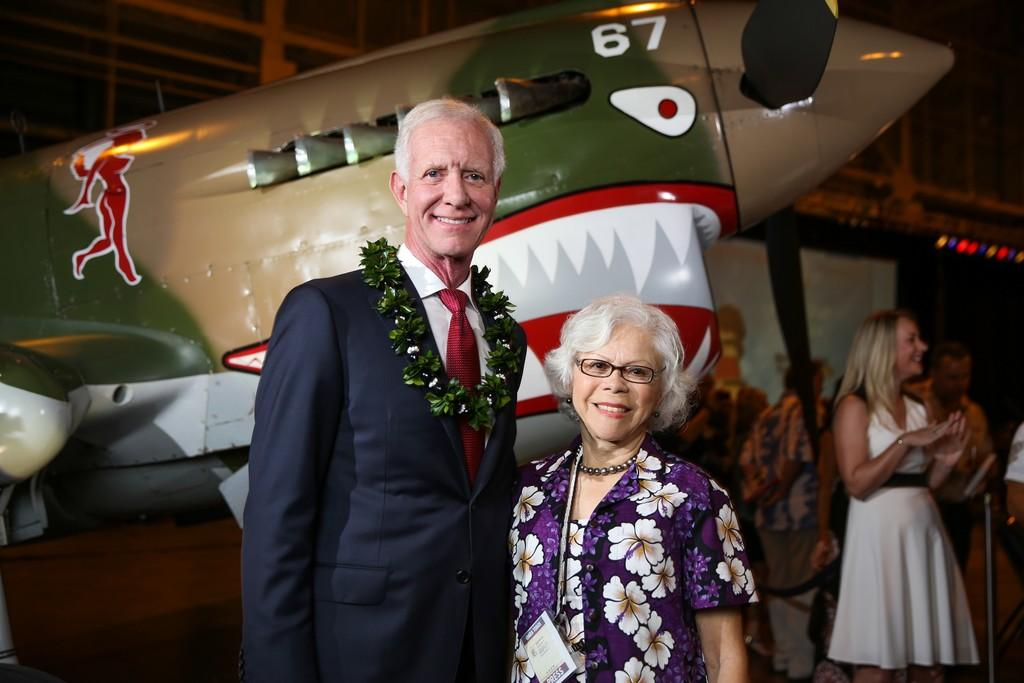Provide a one-sentence caption for the provided image. A couple are posing in front of a fighter plane with the number 67 on the nose. 